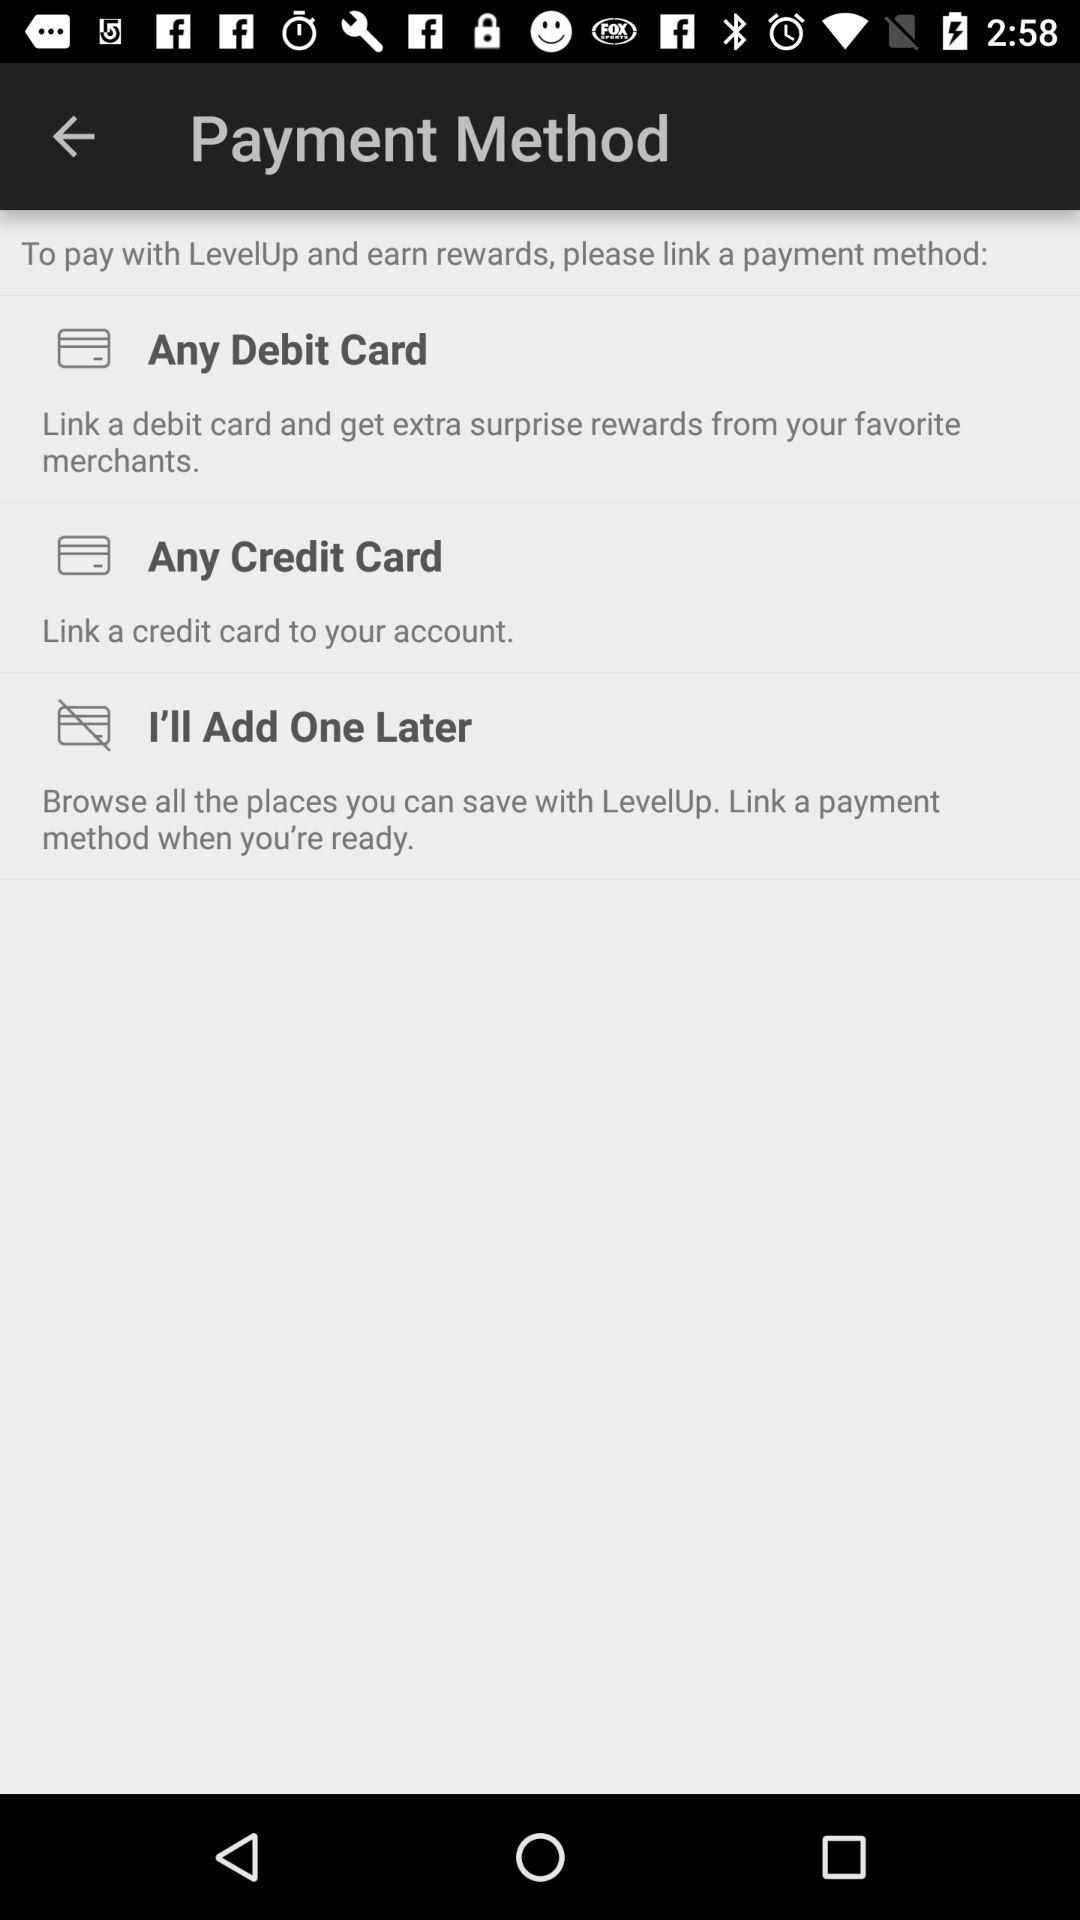How many payment methods are available to link?
Answer the question using a single word or phrase. 2 